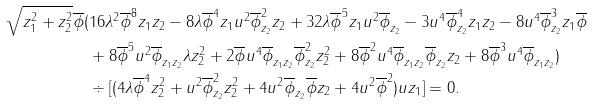Convert formula to latex. <formula><loc_0><loc_0><loc_500><loc_500>\sqrt { z _ { 1 } ^ { 2 } + z _ { 2 } ^ { 2 } } \overline { \phi } ( & 1 6 \lambda ^ { 2 } \overline { \phi } ^ { 8 } z _ { 1 } z _ { 2 } - 8 \lambda \overline { \phi } ^ { 4 } z _ { 1 } u ^ { 2 } \overline { \phi } _ { z _ { 2 } } ^ { 2 } z _ { 2 } + 3 2 \lambda \overline { \phi } ^ { 5 } z _ { 1 } u ^ { 2 } \overline { \phi } _ { z _ { 2 } } - 3 u ^ { 4 } \overline { \phi } _ { z _ { 2 } } ^ { 4 } z _ { 1 } z _ { 2 } - 8 u ^ { 4 } \overline { \phi } _ { z _ { 2 } } ^ { 3 } z _ { 1 } \overline { \phi } \\ & + 8 \overline { \phi } ^ { 5 } u ^ { 2 } \overline { \phi } _ { z _ { 1 } z _ { 2 } } \lambda z _ { 2 } ^ { 2 } + 2 \overline { \phi } u ^ { 4 } \overline { \phi } _ { z _ { 1 } z _ { 2 } } \overline { \phi } _ { z _ { 2 } } ^ { 2 } z _ { 2 } ^ { 2 } + 8 \overline { \phi } ^ { 2 } u ^ { 4 } \overline { \phi } _ { z _ { 1 } z _ { 2 } } \overline { \phi } _ { z _ { 2 } } z _ { 2 } + 8 \overline { \phi } ^ { 3 } u ^ { 4 } \overline { \phi } _ { z _ { 1 } z _ { 2 } } ) \\ & \div [ ( 4 \lambda \overline { \phi } ^ { 4 } z _ { 2 } ^ { 2 } + u ^ { 2 } \overline { \phi } _ { z _ { 2 } } ^ { 2 } z _ { 2 } ^ { 2 } + 4 u ^ { 2 } \overline { \phi } _ { z _ { 2 } } \overline { \phi } z _ { 2 } + 4 u ^ { 2 } \overline { \phi } ^ { 2 } ) u z _ { 1 } ] = 0 .</formula> 